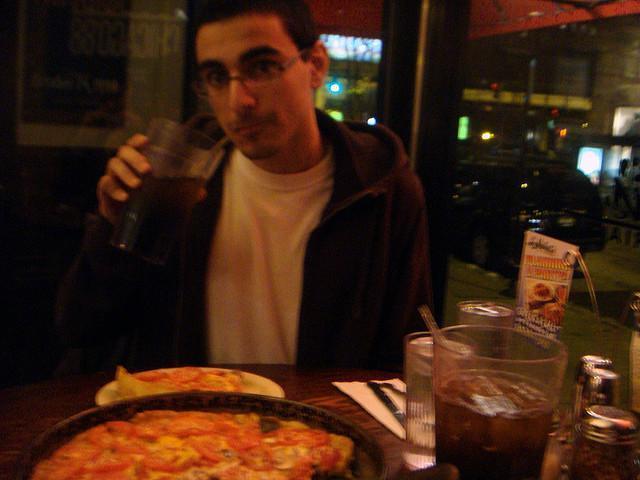How many cups are in the photo?
Give a very brief answer. 3. How many pizzas are in the photo?
Give a very brief answer. 2. 